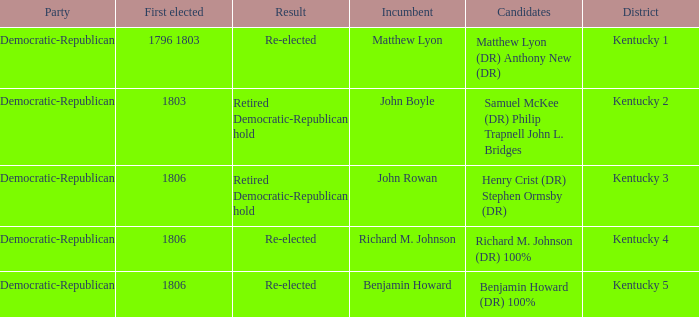Name the first elected for kentucky 1 1796 1803. 